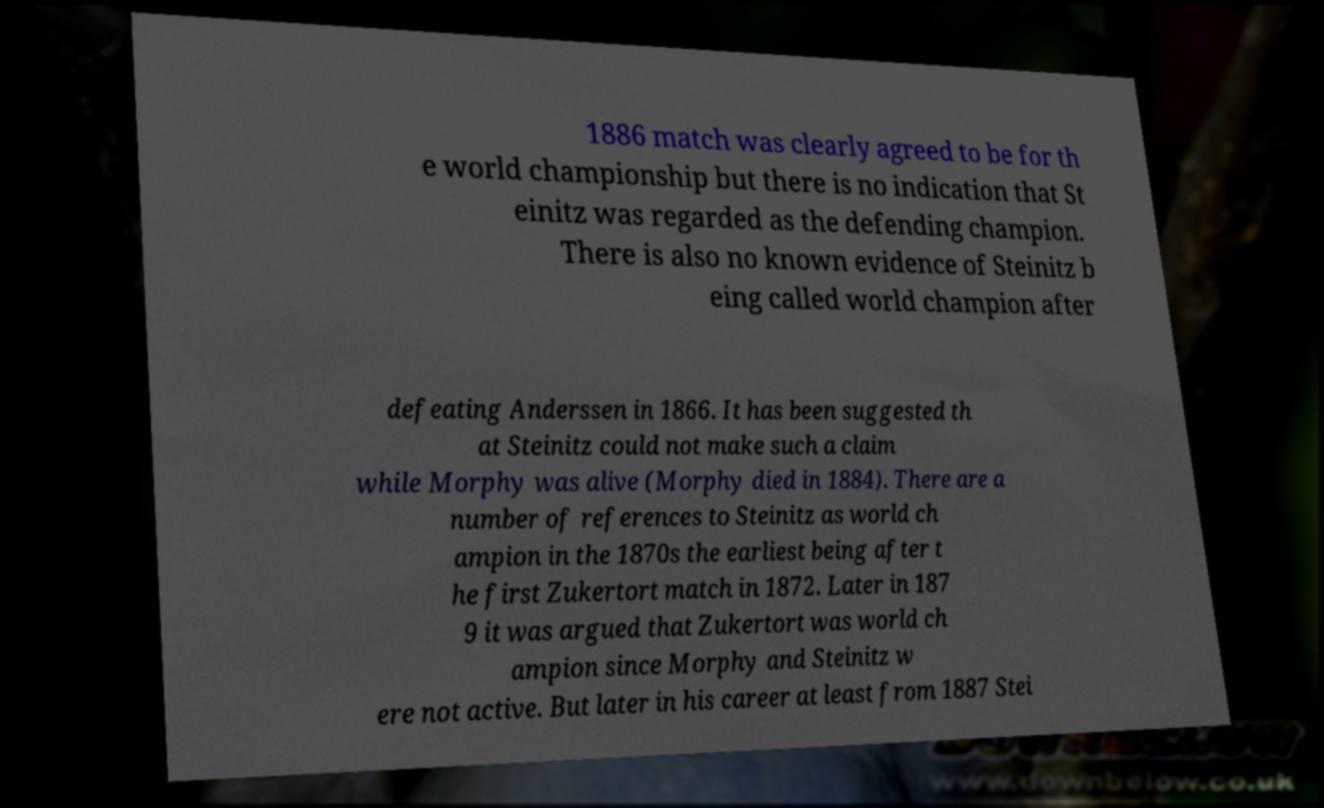There's text embedded in this image that I need extracted. Can you transcribe it verbatim? 1886 match was clearly agreed to be for th e world championship but there is no indication that St einitz was regarded as the defending champion. There is also no known evidence of Steinitz b eing called world champion after defeating Anderssen in 1866. It has been suggested th at Steinitz could not make such a claim while Morphy was alive (Morphy died in 1884). There are a number of references to Steinitz as world ch ampion in the 1870s the earliest being after t he first Zukertort match in 1872. Later in 187 9 it was argued that Zukertort was world ch ampion since Morphy and Steinitz w ere not active. But later in his career at least from 1887 Stei 